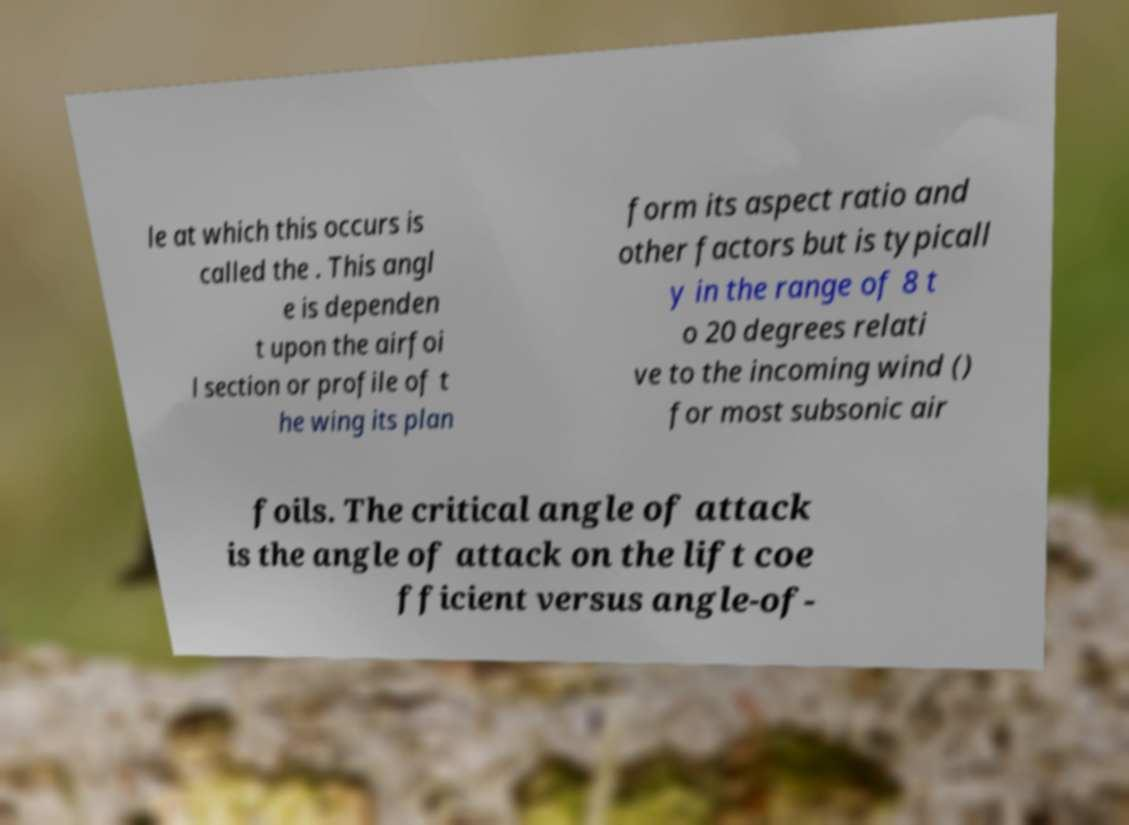Could you assist in decoding the text presented in this image and type it out clearly? le at which this occurs is called the . This angl e is dependen t upon the airfoi l section or profile of t he wing its plan form its aspect ratio and other factors but is typicall y in the range of 8 t o 20 degrees relati ve to the incoming wind () for most subsonic air foils. The critical angle of attack is the angle of attack on the lift coe fficient versus angle-of- 